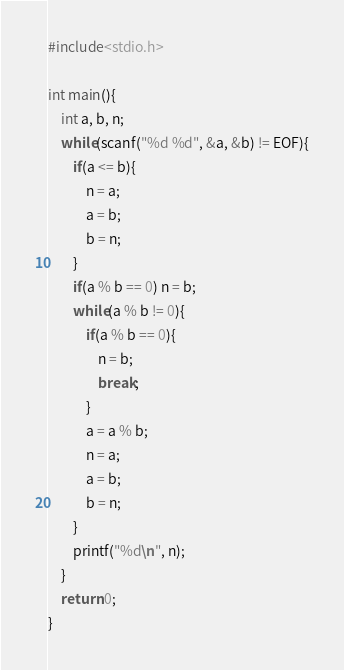<code> <loc_0><loc_0><loc_500><loc_500><_C++_>#include<stdio.h>
 
int main(){
	int a, b, n;
	while(scanf("%d %d", &a, &b) != EOF){
		if(a <= b){
			n = a;
			a = b;
			b = n;
		}
		if(a % b == 0) n = b;
		while(a % b != 0){
			if(a % b == 0){
				n = b;
				break;
			}
			a = a % b;
			n = a;
			a = b;
			b = n;
		}
		printf("%d\n", n);
	}
	return 0;
}</code> 